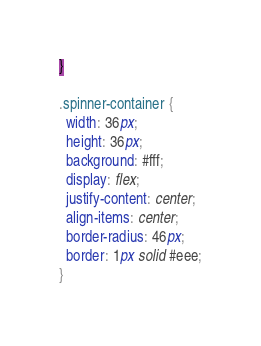Convert code to text. <code><loc_0><loc_0><loc_500><loc_500><_CSS_>}

.spinner-container {
  width: 36px;
  height: 36px;
  background: #fff;
  display: flex;
  justify-content: center;
  align-items: center;
  border-radius: 46px;
  border: 1px solid #eee;
}</code> 